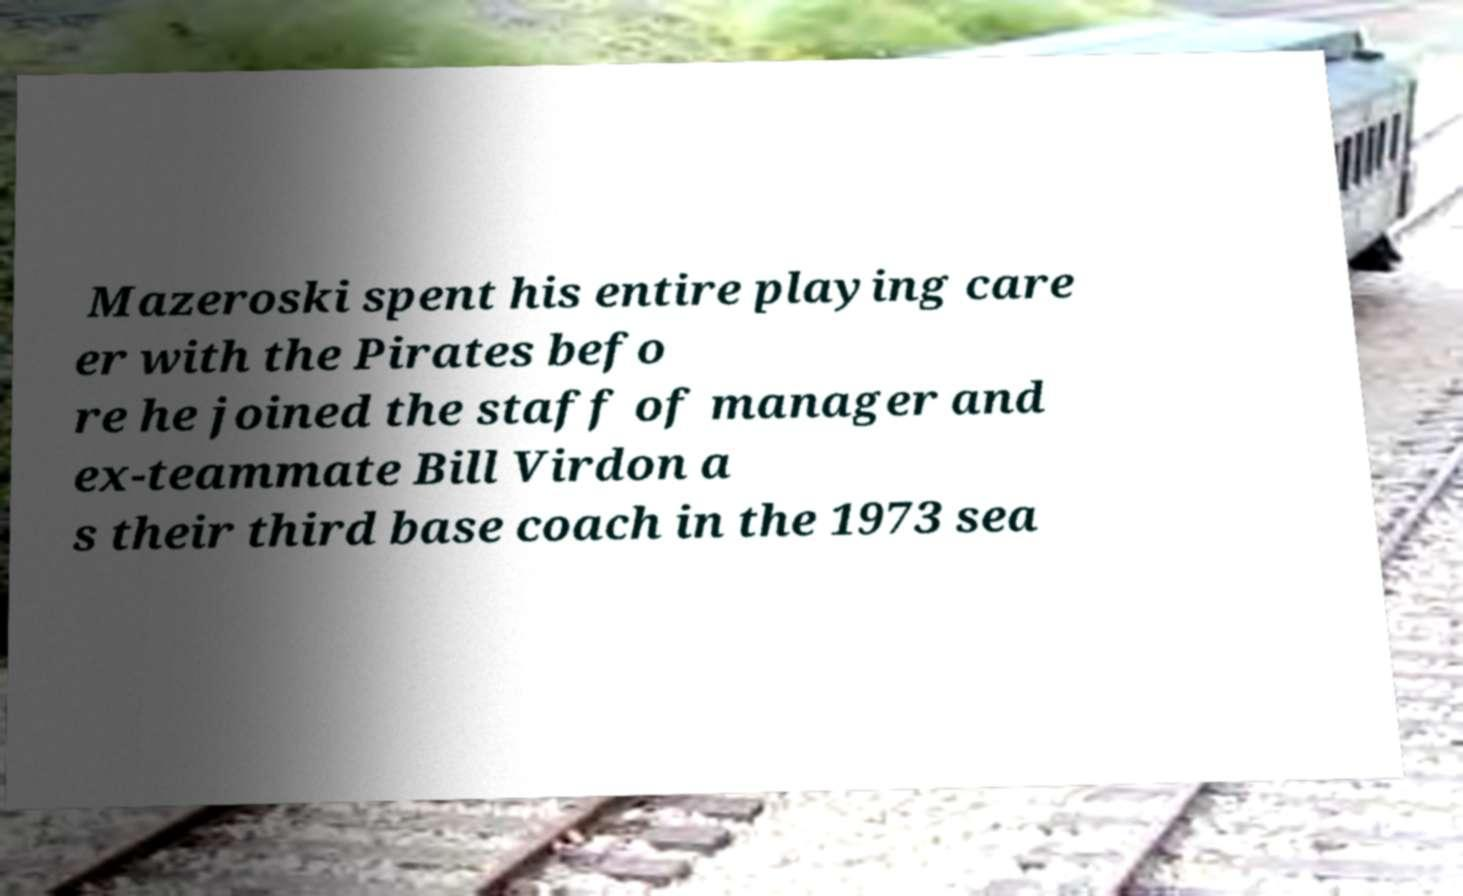I need the written content from this picture converted into text. Can you do that? Mazeroski spent his entire playing care er with the Pirates befo re he joined the staff of manager and ex-teammate Bill Virdon a s their third base coach in the 1973 sea 